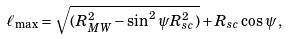<formula> <loc_0><loc_0><loc_500><loc_500>\ell _ { \max } = \sqrt { ( R _ { M W } ^ { 2 } - \sin ^ { 2 } \psi R _ { s c } ^ { 2 } ) } + R _ { s c } \cos \psi \, ,</formula> 